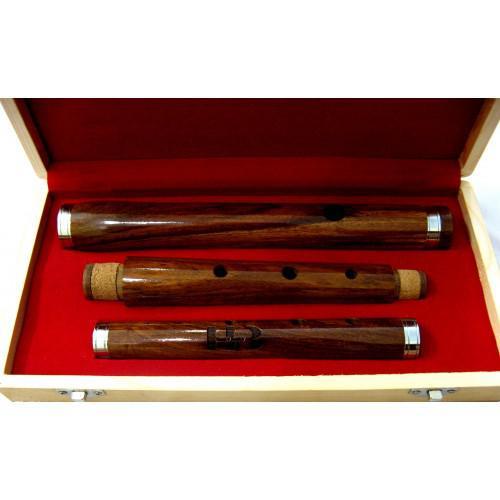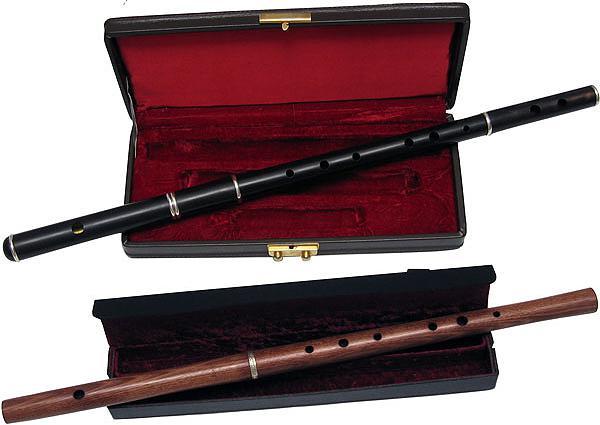The first image is the image on the left, the second image is the image on the right. Examine the images to the left and right. Is the description "Each image includes an open case for an instrument, and in at least one image, an instrument is fully inside the case." accurate? Answer yes or no. Yes. The first image is the image on the left, the second image is the image on the right. Analyze the images presented: Is the assertion "Each image shows instruments in or with a case." valid? Answer yes or no. Yes. 